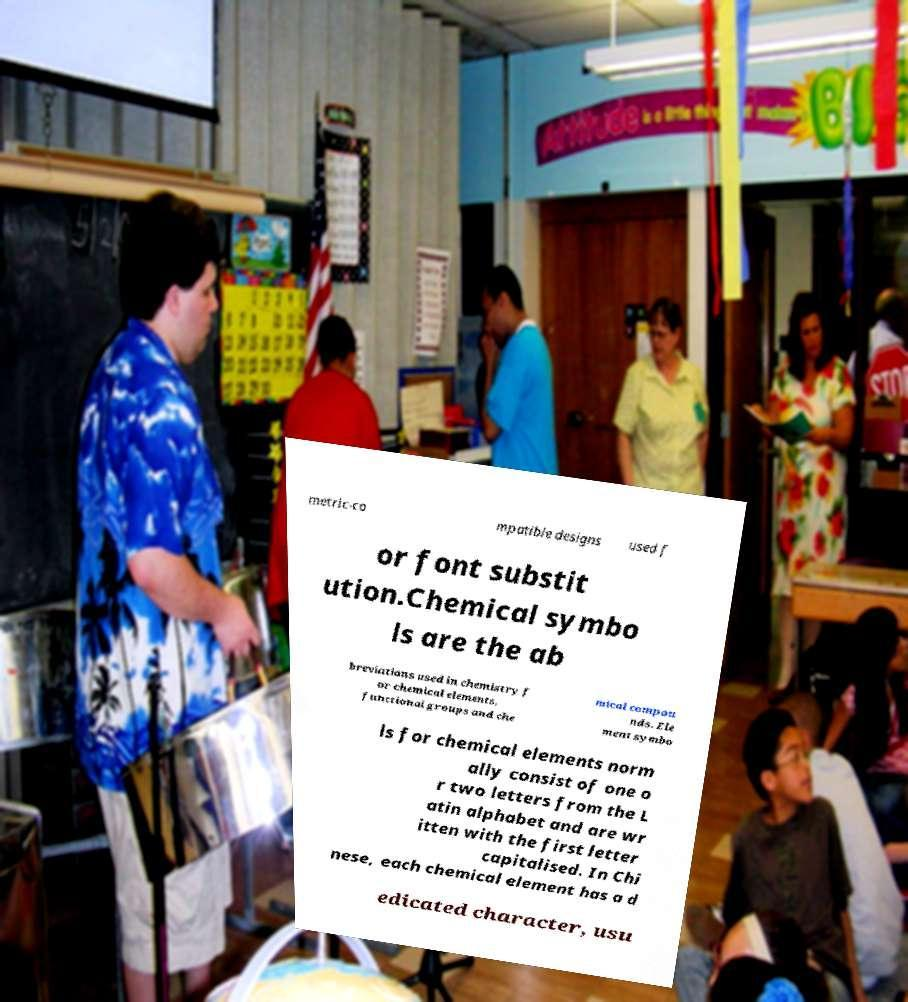Can you accurately transcribe the text from the provided image for me? metric-co mpatible designs used f or font substit ution.Chemical symbo ls are the ab breviations used in chemistry f or chemical elements, functional groups and che mical compou nds. Ele ment symbo ls for chemical elements norm ally consist of one o r two letters from the L atin alphabet and are wr itten with the first letter capitalised. In Chi nese, each chemical element has a d edicated character, usu 